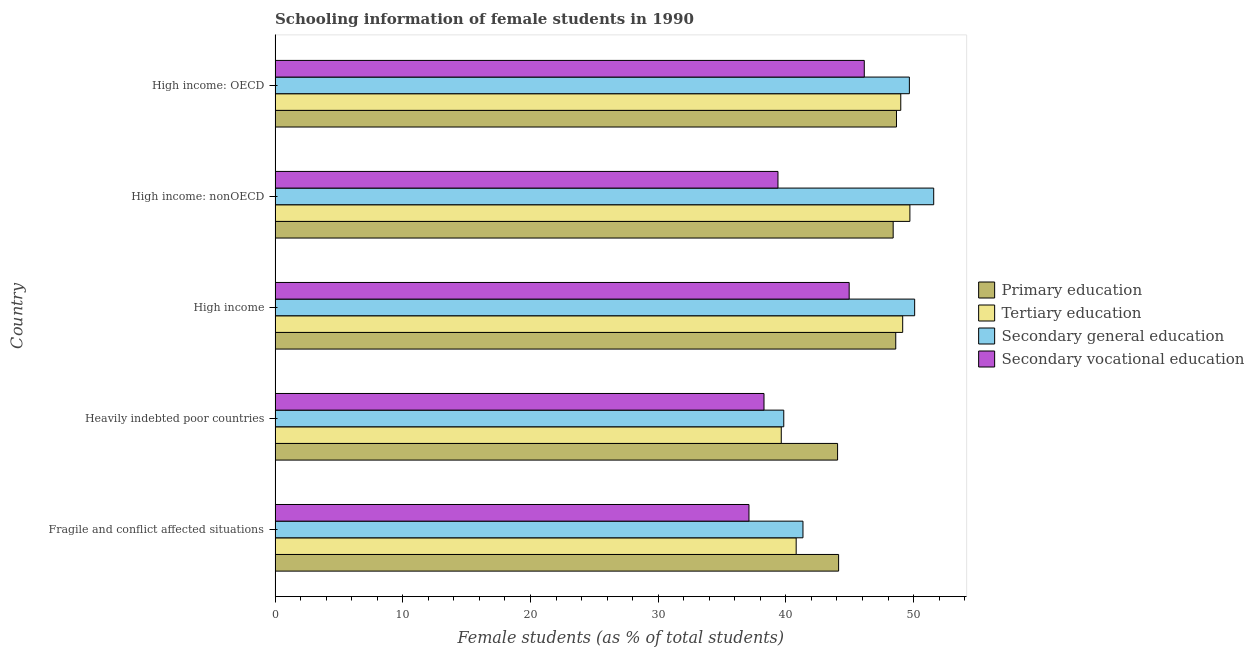How many different coloured bars are there?
Offer a very short reply. 4. How many bars are there on the 4th tick from the top?
Your response must be concise. 4. How many bars are there on the 5th tick from the bottom?
Ensure brevity in your answer.  4. What is the label of the 2nd group of bars from the top?
Your answer should be very brief. High income: nonOECD. In how many cases, is the number of bars for a given country not equal to the number of legend labels?
Provide a succinct answer. 0. What is the percentage of female students in secondary vocational education in High income: nonOECD?
Your answer should be compact. 39.38. Across all countries, what is the maximum percentage of female students in secondary vocational education?
Your answer should be compact. 46.14. Across all countries, what is the minimum percentage of female students in secondary vocational education?
Your response must be concise. 37.11. In which country was the percentage of female students in secondary education maximum?
Keep it short and to the point. High income: nonOECD. In which country was the percentage of female students in secondary education minimum?
Give a very brief answer. Heavily indebted poor countries. What is the total percentage of female students in primary education in the graph?
Ensure brevity in your answer.  233.85. What is the difference between the percentage of female students in primary education in High income and that in High income: nonOECD?
Keep it short and to the point. 0.2. What is the difference between the percentage of female students in tertiary education in High income and the percentage of female students in primary education in Heavily indebted poor countries?
Ensure brevity in your answer.  5.1. What is the average percentage of female students in tertiary education per country?
Keep it short and to the point. 45.66. What is the difference between the percentage of female students in primary education and percentage of female students in tertiary education in Heavily indebted poor countries?
Your answer should be very brief. 4.41. Is the difference between the percentage of female students in secondary vocational education in Fragile and conflict affected situations and High income: OECD greater than the difference between the percentage of female students in primary education in Fragile and conflict affected situations and High income: OECD?
Make the answer very short. No. What is the difference between the highest and the second highest percentage of female students in secondary vocational education?
Your response must be concise. 1.18. What is the difference between the highest and the lowest percentage of female students in secondary education?
Keep it short and to the point. 11.74. In how many countries, is the percentage of female students in tertiary education greater than the average percentage of female students in tertiary education taken over all countries?
Your response must be concise. 3. Is the sum of the percentage of female students in secondary education in Heavily indebted poor countries and High income: nonOECD greater than the maximum percentage of female students in primary education across all countries?
Provide a succinct answer. Yes. What does the 2nd bar from the top in High income represents?
Give a very brief answer. Secondary general education. What does the 4th bar from the bottom in High income: nonOECD represents?
Make the answer very short. Secondary vocational education. Are all the bars in the graph horizontal?
Make the answer very short. Yes. How many countries are there in the graph?
Provide a succinct answer. 5. What is the difference between two consecutive major ticks on the X-axis?
Provide a short and direct response. 10. Does the graph contain grids?
Make the answer very short. No. What is the title of the graph?
Your response must be concise. Schooling information of female students in 1990. What is the label or title of the X-axis?
Your answer should be very brief. Female students (as % of total students). What is the Female students (as % of total students) in Primary education in Fragile and conflict affected situations?
Provide a short and direct response. 44.13. What is the Female students (as % of total students) in Tertiary education in Fragile and conflict affected situations?
Keep it short and to the point. 40.81. What is the Female students (as % of total students) in Secondary general education in Fragile and conflict affected situations?
Your answer should be very brief. 41.34. What is the Female students (as % of total students) of Secondary vocational education in Fragile and conflict affected situations?
Keep it short and to the point. 37.11. What is the Female students (as % of total students) of Primary education in Heavily indebted poor countries?
Ensure brevity in your answer.  44.05. What is the Female students (as % of total students) in Tertiary education in Heavily indebted poor countries?
Your response must be concise. 39.64. What is the Female students (as % of total students) in Secondary general education in Heavily indebted poor countries?
Offer a very short reply. 39.84. What is the Female students (as % of total students) of Secondary vocational education in Heavily indebted poor countries?
Offer a terse response. 38.29. What is the Female students (as % of total students) of Primary education in High income?
Provide a succinct answer. 48.61. What is the Female students (as % of total students) of Tertiary education in High income?
Provide a succinct answer. 49.15. What is the Female students (as % of total students) of Secondary general education in High income?
Ensure brevity in your answer.  50.08. What is the Female students (as % of total students) in Secondary vocational education in High income?
Ensure brevity in your answer.  44.96. What is the Female students (as % of total students) of Primary education in High income: nonOECD?
Give a very brief answer. 48.4. What is the Female students (as % of total students) of Tertiary education in High income: nonOECD?
Keep it short and to the point. 49.71. What is the Female students (as % of total students) of Secondary general education in High income: nonOECD?
Keep it short and to the point. 51.58. What is the Female students (as % of total students) in Secondary vocational education in High income: nonOECD?
Your response must be concise. 39.38. What is the Female students (as % of total students) of Primary education in High income: OECD?
Ensure brevity in your answer.  48.66. What is the Female students (as % of total students) in Tertiary education in High income: OECD?
Your answer should be compact. 49. What is the Female students (as % of total students) in Secondary general education in High income: OECD?
Provide a short and direct response. 49.67. What is the Female students (as % of total students) in Secondary vocational education in High income: OECD?
Make the answer very short. 46.14. Across all countries, what is the maximum Female students (as % of total students) of Primary education?
Make the answer very short. 48.66. Across all countries, what is the maximum Female students (as % of total students) of Tertiary education?
Ensure brevity in your answer.  49.71. Across all countries, what is the maximum Female students (as % of total students) in Secondary general education?
Offer a terse response. 51.58. Across all countries, what is the maximum Female students (as % of total students) in Secondary vocational education?
Your answer should be very brief. 46.14. Across all countries, what is the minimum Female students (as % of total students) of Primary education?
Offer a very short reply. 44.05. Across all countries, what is the minimum Female students (as % of total students) in Tertiary education?
Offer a very short reply. 39.64. Across all countries, what is the minimum Female students (as % of total students) of Secondary general education?
Make the answer very short. 39.84. Across all countries, what is the minimum Female students (as % of total students) of Secondary vocational education?
Ensure brevity in your answer.  37.11. What is the total Female students (as % of total students) in Primary education in the graph?
Give a very brief answer. 233.85. What is the total Female students (as % of total students) of Tertiary education in the graph?
Keep it short and to the point. 228.3. What is the total Female students (as % of total students) in Secondary general education in the graph?
Your response must be concise. 232.51. What is the total Female students (as % of total students) in Secondary vocational education in the graph?
Your answer should be compact. 205.88. What is the difference between the Female students (as % of total students) in Primary education in Fragile and conflict affected situations and that in Heavily indebted poor countries?
Offer a very short reply. 0.08. What is the difference between the Female students (as % of total students) in Tertiary education in Fragile and conflict affected situations and that in Heavily indebted poor countries?
Provide a succinct answer. 1.17. What is the difference between the Female students (as % of total students) of Secondary general education in Fragile and conflict affected situations and that in Heavily indebted poor countries?
Offer a terse response. 1.5. What is the difference between the Female students (as % of total students) in Secondary vocational education in Fragile and conflict affected situations and that in Heavily indebted poor countries?
Your response must be concise. -1.18. What is the difference between the Female students (as % of total students) in Primary education in Fragile and conflict affected situations and that in High income?
Your answer should be compact. -4.47. What is the difference between the Female students (as % of total students) of Tertiary education in Fragile and conflict affected situations and that in High income?
Provide a succinct answer. -8.34. What is the difference between the Female students (as % of total students) in Secondary general education in Fragile and conflict affected situations and that in High income?
Your answer should be very brief. -8.75. What is the difference between the Female students (as % of total students) in Secondary vocational education in Fragile and conflict affected situations and that in High income?
Provide a short and direct response. -7.85. What is the difference between the Female students (as % of total students) of Primary education in Fragile and conflict affected situations and that in High income: nonOECD?
Your response must be concise. -4.27. What is the difference between the Female students (as % of total students) in Tertiary education in Fragile and conflict affected situations and that in High income: nonOECD?
Offer a very short reply. -8.9. What is the difference between the Female students (as % of total students) of Secondary general education in Fragile and conflict affected situations and that in High income: nonOECD?
Give a very brief answer. -10.24. What is the difference between the Female students (as % of total students) of Secondary vocational education in Fragile and conflict affected situations and that in High income: nonOECD?
Offer a terse response. -2.27. What is the difference between the Female students (as % of total students) of Primary education in Fragile and conflict affected situations and that in High income: OECD?
Provide a succinct answer. -4.53. What is the difference between the Female students (as % of total students) of Tertiary education in Fragile and conflict affected situations and that in High income: OECD?
Your response must be concise. -8.19. What is the difference between the Female students (as % of total students) of Secondary general education in Fragile and conflict affected situations and that in High income: OECD?
Ensure brevity in your answer.  -8.33. What is the difference between the Female students (as % of total students) in Secondary vocational education in Fragile and conflict affected situations and that in High income: OECD?
Provide a short and direct response. -9.03. What is the difference between the Female students (as % of total students) of Primary education in Heavily indebted poor countries and that in High income?
Ensure brevity in your answer.  -4.56. What is the difference between the Female students (as % of total students) in Tertiary education in Heavily indebted poor countries and that in High income?
Your answer should be very brief. -9.51. What is the difference between the Female students (as % of total students) of Secondary general education in Heavily indebted poor countries and that in High income?
Provide a succinct answer. -10.25. What is the difference between the Female students (as % of total students) of Secondary vocational education in Heavily indebted poor countries and that in High income?
Keep it short and to the point. -6.67. What is the difference between the Female students (as % of total students) in Primary education in Heavily indebted poor countries and that in High income: nonOECD?
Your response must be concise. -4.35. What is the difference between the Female students (as % of total students) of Tertiary education in Heavily indebted poor countries and that in High income: nonOECD?
Make the answer very short. -10.07. What is the difference between the Female students (as % of total students) of Secondary general education in Heavily indebted poor countries and that in High income: nonOECD?
Offer a very short reply. -11.74. What is the difference between the Female students (as % of total students) of Secondary vocational education in Heavily indebted poor countries and that in High income: nonOECD?
Your response must be concise. -1.09. What is the difference between the Female students (as % of total students) of Primary education in Heavily indebted poor countries and that in High income: OECD?
Provide a short and direct response. -4.61. What is the difference between the Female students (as % of total students) of Tertiary education in Heavily indebted poor countries and that in High income: OECD?
Keep it short and to the point. -9.36. What is the difference between the Female students (as % of total students) in Secondary general education in Heavily indebted poor countries and that in High income: OECD?
Provide a succinct answer. -9.84. What is the difference between the Female students (as % of total students) of Secondary vocational education in Heavily indebted poor countries and that in High income: OECD?
Keep it short and to the point. -7.85. What is the difference between the Female students (as % of total students) in Primary education in High income and that in High income: nonOECD?
Give a very brief answer. 0.2. What is the difference between the Female students (as % of total students) of Tertiary education in High income and that in High income: nonOECD?
Give a very brief answer. -0.56. What is the difference between the Female students (as % of total students) in Secondary general education in High income and that in High income: nonOECD?
Your response must be concise. -1.49. What is the difference between the Female students (as % of total students) in Secondary vocational education in High income and that in High income: nonOECD?
Your answer should be very brief. 5.58. What is the difference between the Female students (as % of total students) of Primary education in High income and that in High income: OECD?
Your answer should be very brief. -0.06. What is the difference between the Female students (as % of total students) of Tertiary education in High income and that in High income: OECD?
Your answer should be very brief. 0.15. What is the difference between the Female students (as % of total students) in Secondary general education in High income and that in High income: OECD?
Keep it short and to the point. 0.41. What is the difference between the Female students (as % of total students) of Secondary vocational education in High income and that in High income: OECD?
Your response must be concise. -1.18. What is the difference between the Female students (as % of total students) in Primary education in High income: nonOECD and that in High income: OECD?
Offer a terse response. -0.26. What is the difference between the Female students (as % of total students) in Tertiary education in High income: nonOECD and that in High income: OECD?
Keep it short and to the point. 0.71. What is the difference between the Female students (as % of total students) in Secondary general education in High income: nonOECD and that in High income: OECD?
Your answer should be very brief. 1.91. What is the difference between the Female students (as % of total students) of Secondary vocational education in High income: nonOECD and that in High income: OECD?
Give a very brief answer. -6.76. What is the difference between the Female students (as % of total students) in Primary education in Fragile and conflict affected situations and the Female students (as % of total students) in Tertiary education in Heavily indebted poor countries?
Offer a terse response. 4.49. What is the difference between the Female students (as % of total students) in Primary education in Fragile and conflict affected situations and the Female students (as % of total students) in Secondary general education in Heavily indebted poor countries?
Your response must be concise. 4.3. What is the difference between the Female students (as % of total students) of Primary education in Fragile and conflict affected situations and the Female students (as % of total students) of Secondary vocational education in Heavily indebted poor countries?
Keep it short and to the point. 5.84. What is the difference between the Female students (as % of total students) of Tertiary education in Fragile and conflict affected situations and the Female students (as % of total students) of Secondary general education in Heavily indebted poor countries?
Your answer should be compact. 0.97. What is the difference between the Female students (as % of total students) in Tertiary education in Fragile and conflict affected situations and the Female students (as % of total students) in Secondary vocational education in Heavily indebted poor countries?
Give a very brief answer. 2.52. What is the difference between the Female students (as % of total students) of Secondary general education in Fragile and conflict affected situations and the Female students (as % of total students) of Secondary vocational education in Heavily indebted poor countries?
Offer a terse response. 3.05. What is the difference between the Female students (as % of total students) in Primary education in Fragile and conflict affected situations and the Female students (as % of total students) in Tertiary education in High income?
Make the answer very short. -5.02. What is the difference between the Female students (as % of total students) of Primary education in Fragile and conflict affected situations and the Female students (as % of total students) of Secondary general education in High income?
Keep it short and to the point. -5.95. What is the difference between the Female students (as % of total students) in Primary education in Fragile and conflict affected situations and the Female students (as % of total students) in Secondary vocational education in High income?
Make the answer very short. -0.83. What is the difference between the Female students (as % of total students) in Tertiary education in Fragile and conflict affected situations and the Female students (as % of total students) in Secondary general education in High income?
Ensure brevity in your answer.  -9.28. What is the difference between the Female students (as % of total students) of Tertiary education in Fragile and conflict affected situations and the Female students (as % of total students) of Secondary vocational education in High income?
Your answer should be compact. -4.15. What is the difference between the Female students (as % of total students) in Secondary general education in Fragile and conflict affected situations and the Female students (as % of total students) in Secondary vocational education in High income?
Your answer should be compact. -3.62. What is the difference between the Female students (as % of total students) of Primary education in Fragile and conflict affected situations and the Female students (as % of total students) of Tertiary education in High income: nonOECD?
Make the answer very short. -5.58. What is the difference between the Female students (as % of total students) of Primary education in Fragile and conflict affected situations and the Female students (as % of total students) of Secondary general education in High income: nonOECD?
Offer a very short reply. -7.45. What is the difference between the Female students (as % of total students) in Primary education in Fragile and conflict affected situations and the Female students (as % of total students) in Secondary vocational education in High income: nonOECD?
Offer a very short reply. 4.75. What is the difference between the Female students (as % of total students) of Tertiary education in Fragile and conflict affected situations and the Female students (as % of total students) of Secondary general education in High income: nonOECD?
Give a very brief answer. -10.77. What is the difference between the Female students (as % of total students) in Tertiary education in Fragile and conflict affected situations and the Female students (as % of total students) in Secondary vocational education in High income: nonOECD?
Offer a terse response. 1.43. What is the difference between the Female students (as % of total students) of Secondary general education in Fragile and conflict affected situations and the Female students (as % of total students) of Secondary vocational education in High income: nonOECD?
Offer a terse response. 1.96. What is the difference between the Female students (as % of total students) in Primary education in Fragile and conflict affected situations and the Female students (as % of total students) in Tertiary education in High income: OECD?
Your answer should be very brief. -4.87. What is the difference between the Female students (as % of total students) in Primary education in Fragile and conflict affected situations and the Female students (as % of total students) in Secondary general education in High income: OECD?
Ensure brevity in your answer.  -5.54. What is the difference between the Female students (as % of total students) of Primary education in Fragile and conflict affected situations and the Female students (as % of total students) of Secondary vocational education in High income: OECD?
Make the answer very short. -2.01. What is the difference between the Female students (as % of total students) in Tertiary education in Fragile and conflict affected situations and the Female students (as % of total students) in Secondary general education in High income: OECD?
Provide a succinct answer. -8.86. What is the difference between the Female students (as % of total students) of Tertiary education in Fragile and conflict affected situations and the Female students (as % of total students) of Secondary vocational education in High income: OECD?
Offer a terse response. -5.33. What is the difference between the Female students (as % of total students) of Secondary general education in Fragile and conflict affected situations and the Female students (as % of total students) of Secondary vocational education in High income: OECD?
Your response must be concise. -4.8. What is the difference between the Female students (as % of total students) in Primary education in Heavily indebted poor countries and the Female students (as % of total students) in Tertiary education in High income?
Ensure brevity in your answer.  -5.1. What is the difference between the Female students (as % of total students) of Primary education in Heavily indebted poor countries and the Female students (as % of total students) of Secondary general education in High income?
Provide a short and direct response. -6.04. What is the difference between the Female students (as % of total students) in Primary education in Heavily indebted poor countries and the Female students (as % of total students) in Secondary vocational education in High income?
Your answer should be compact. -0.91. What is the difference between the Female students (as % of total students) of Tertiary education in Heavily indebted poor countries and the Female students (as % of total students) of Secondary general education in High income?
Offer a very short reply. -10.45. What is the difference between the Female students (as % of total students) in Tertiary education in Heavily indebted poor countries and the Female students (as % of total students) in Secondary vocational education in High income?
Offer a very short reply. -5.32. What is the difference between the Female students (as % of total students) in Secondary general education in Heavily indebted poor countries and the Female students (as % of total students) in Secondary vocational education in High income?
Give a very brief answer. -5.12. What is the difference between the Female students (as % of total students) of Primary education in Heavily indebted poor countries and the Female students (as % of total students) of Tertiary education in High income: nonOECD?
Make the answer very short. -5.66. What is the difference between the Female students (as % of total students) of Primary education in Heavily indebted poor countries and the Female students (as % of total students) of Secondary general education in High income: nonOECD?
Your answer should be very brief. -7.53. What is the difference between the Female students (as % of total students) of Primary education in Heavily indebted poor countries and the Female students (as % of total students) of Secondary vocational education in High income: nonOECD?
Give a very brief answer. 4.67. What is the difference between the Female students (as % of total students) of Tertiary education in Heavily indebted poor countries and the Female students (as % of total students) of Secondary general education in High income: nonOECD?
Offer a very short reply. -11.94. What is the difference between the Female students (as % of total students) of Tertiary education in Heavily indebted poor countries and the Female students (as % of total students) of Secondary vocational education in High income: nonOECD?
Provide a short and direct response. 0.26. What is the difference between the Female students (as % of total students) of Secondary general education in Heavily indebted poor countries and the Female students (as % of total students) of Secondary vocational education in High income: nonOECD?
Ensure brevity in your answer.  0.45. What is the difference between the Female students (as % of total students) of Primary education in Heavily indebted poor countries and the Female students (as % of total students) of Tertiary education in High income: OECD?
Offer a very short reply. -4.95. What is the difference between the Female students (as % of total students) of Primary education in Heavily indebted poor countries and the Female students (as % of total students) of Secondary general education in High income: OECD?
Offer a terse response. -5.62. What is the difference between the Female students (as % of total students) of Primary education in Heavily indebted poor countries and the Female students (as % of total students) of Secondary vocational education in High income: OECD?
Keep it short and to the point. -2.09. What is the difference between the Female students (as % of total students) in Tertiary education in Heavily indebted poor countries and the Female students (as % of total students) in Secondary general education in High income: OECD?
Make the answer very short. -10.03. What is the difference between the Female students (as % of total students) of Tertiary education in Heavily indebted poor countries and the Female students (as % of total students) of Secondary vocational education in High income: OECD?
Provide a succinct answer. -6.5. What is the difference between the Female students (as % of total students) in Secondary general education in Heavily indebted poor countries and the Female students (as % of total students) in Secondary vocational education in High income: OECD?
Your answer should be very brief. -6.3. What is the difference between the Female students (as % of total students) of Primary education in High income and the Female students (as % of total students) of Tertiary education in High income: nonOECD?
Your response must be concise. -1.11. What is the difference between the Female students (as % of total students) in Primary education in High income and the Female students (as % of total students) in Secondary general education in High income: nonOECD?
Provide a succinct answer. -2.97. What is the difference between the Female students (as % of total students) in Primary education in High income and the Female students (as % of total students) in Secondary vocational education in High income: nonOECD?
Provide a succinct answer. 9.22. What is the difference between the Female students (as % of total students) of Tertiary education in High income and the Female students (as % of total students) of Secondary general education in High income: nonOECD?
Offer a terse response. -2.43. What is the difference between the Female students (as % of total students) of Tertiary education in High income and the Female students (as % of total students) of Secondary vocational education in High income: nonOECD?
Ensure brevity in your answer.  9.77. What is the difference between the Female students (as % of total students) in Secondary general education in High income and the Female students (as % of total students) in Secondary vocational education in High income: nonOECD?
Offer a terse response. 10.7. What is the difference between the Female students (as % of total students) in Primary education in High income and the Female students (as % of total students) in Tertiary education in High income: OECD?
Provide a short and direct response. -0.39. What is the difference between the Female students (as % of total students) in Primary education in High income and the Female students (as % of total students) in Secondary general education in High income: OECD?
Your answer should be compact. -1.07. What is the difference between the Female students (as % of total students) of Primary education in High income and the Female students (as % of total students) of Secondary vocational education in High income: OECD?
Provide a short and direct response. 2.47. What is the difference between the Female students (as % of total students) in Tertiary education in High income and the Female students (as % of total students) in Secondary general education in High income: OECD?
Keep it short and to the point. -0.52. What is the difference between the Female students (as % of total students) of Tertiary education in High income and the Female students (as % of total students) of Secondary vocational education in High income: OECD?
Your answer should be very brief. 3.01. What is the difference between the Female students (as % of total students) of Secondary general education in High income and the Female students (as % of total students) of Secondary vocational education in High income: OECD?
Keep it short and to the point. 3.94. What is the difference between the Female students (as % of total students) in Primary education in High income: nonOECD and the Female students (as % of total students) in Tertiary education in High income: OECD?
Offer a terse response. -0.6. What is the difference between the Female students (as % of total students) in Primary education in High income: nonOECD and the Female students (as % of total students) in Secondary general education in High income: OECD?
Your answer should be very brief. -1.27. What is the difference between the Female students (as % of total students) in Primary education in High income: nonOECD and the Female students (as % of total students) in Secondary vocational education in High income: OECD?
Your answer should be compact. 2.26. What is the difference between the Female students (as % of total students) of Tertiary education in High income: nonOECD and the Female students (as % of total students) of Secondary general education in High income: OECD?
Make the answer very short. 0.04. What is the difference between the Female students (as % of total students) of Tertiary education in High income: nonOECD and the Female students (as % of total students) of Secondary vocational education in High income: OECD?
Your answer should be very brief. 3.57. What is the difference between the Female students (as % of total students) of Secondary general education in High income: nonOECD and the Female students (as % of total students) of Secondary vocational education in High income: OECD?
Provide a short and direct response. 5.44. What is the average Female students (as % of total students) in Primary education per country?
Offer a terse response. 46.77. What is the average Female students (as % of total students) of Tertiary education per country?
Ensure brevity in your answer.  45.66. What is the average Female students (as % of total students) in Secondary general education per country?
Your answer should be compact. 46.5. What is the average Female students (as % of total students) of Secondary vocational education per country?
Keep it short and to the point. 41.18. What is the difference between the Female students (as % of total students) of Primary education and Female students (as % of total students) of Tertiary education in Fragile and conflict affected situations?
Make the answer very short. 3.32. What is the difference between the Female students (as % of total students) of Primary education and Female students (as % of total students) of Secondary general education in Fragile and conflict affected situations?
Give a very brief answer. 2.79. What is the difference between the Female students (as % of total students) in Primary education and Female students (as % of total students) in Secondary vocational education in Fragile and conflict affected situations?
Offer a terse response. 7.02. What is the difference between the Female students (as % of total students) in Tertiary education and Female students (as % of total students) in Secondary general education in Fragile and conflict affected situations?
Offer a very short reply. -0.53. What is the difference between the Female students (as % of total students) of Tertiary education and Female students (as % of total students) of Secondary vocational education in Fragile and conflict affected situations?
Ensure brevity in your answer.  3.7. What is the difference between the Female students (as % of total students) of Secondary general education and Female students (as % of total students) of Secondary vocational education in Fragile and conflict affected situations?
Your answer should be compact. 4.23. What is the difference between the Female students (as % of total students) of Primary education and Female students (as % of total students) of Tertiary education in Heavily indebted poor countries?
Make the answer very short. 4.41. What is the difference between the Female students (as % of total students) of Primary education and Female students (as % of total students) of Secondary general education in Heavily indebted poor countries?
Keep it short and to the point. 4.21. What is the difference between the Female students (as % of total students) of Primary education and Female students (as % of total students) of Secondary vocational education in Heavily indebted poor countries?
Your response must be concise. 5.76. What is the difference between the Female students (as % of total students) in Tertiary education and Female students (as % of total students) in Secondary general education in Heavily indebted poor countries?
Your answer should be compact. -0.2. What is the difference between the Female students (as % of total students) in Tertiary education and Female students (as % of total students) in Secondary vocational education in Heavily indebted poor countries?
Make the answer very short. 1.35. What is the difference between the Female students (as % of total students) in Secondary general education and Female students (as % of total students) in Secondary vocational education in Heavily indebted poor countries?
Your response must be concise. 1.55. What is the difference between the Female students (as % of total students) in Primary education and Female students (as % of total students) in Tertiary education in High income?
Offer a very short reply. -0.54. What is the difference between the Female students (as % of total students) of Primary education and Female students (as % of total students) of Secondary general education in High income?
Your answer should be compact. -1.48. What is the difference between the Female students (as % of total students) of Primary education and Female students (as % of total students) of Secondary vocational education in High income?
Keep it short and to the point. 3.65. What is the difference between the Female students (as % of total students) of Tertiary education and Female students (as % of total students) of Secondary general education in High income?
Keep it short and to the point. -0.94. What is the difference between the Female students (as % of total students) of Tertiary education and Female students (as % of total students) of Secondary vocational education in High income?
Provide a short and direct response. 4.19. What is the difference between the Female students (as % of total students) in Secondary general education and Female students (as % of total students) in Secondary vocational education in High income?
Your answer should be very brief. 5.13. What is the difference between the Female students (as % of total students) in Primary education and Female students (as % of total students) in Tertiary education in High income: nonOECD?
Offer a very short reply. -1.31. What is the difference between the Female students (as % of total students) of Primary education and Female students (as % of total students) of Secondary general education in High income: nonOECD?
Ensure brevity in your answer.  -3.17. What is the difference between the Female students (as % of total students) in Primary education and Female students (as % of total students) in Secondary vocational education in High income: nonOECD?
Make the answer very short. 9.02. What is the difference between the Female students (as % of total students) in Tertiary education and Female students (as % of total students) in Secondary general education in High income: nonOECD?
Provide a succinct answer. -1.86. What is the difference between the Female students (as % of total students) in Tertiary education and Female students (as % of total students) in Secondary vocational education in High income: nonOECD?
Your answer should be compact. 10.33. What is the difference between the Female students (as % of total students) of Secondary general education and Female students (as % of total students) of Secondary vocational education in High income: nonOECD?
Give a very brief answer. 12.2. What is the difference between the Female students (as % of total students) in Primary education and Female students (as % of total students) in Tertiary education in High income: OECD?
Your answer should be compact. -0.34. What is the difference between the Female students (as % of total students) of Primary education and Female students (as % of total students) of Secondary general education in High income: OECD?
Provide a succinct answer. -1.01. What is the difference between the Female students (as % of total students) in Primary education and Female students (as % of total students) in Secondary vocational education in High income: OECD?
Make the answer very short. 2.52. What is the difference between the Female students (as % of total students) of Tertiary education and Female students (as % of total students) of Secondary general education in High income: OECD?
Keep it short and to the point. -0.67. What is the difference between the Female students (as % of total students) in Tertiary education and Female students (as % of total students) in Secondary vocational education in High income: OECD?
Provide a succinct answer. 2.86. What is the difference between the Female students (as % of total students) in Secondary general education and Female students (as % of total students) in Secondary vocational education in High income: OECD?
Keep it short and to the point. 3.53. What is the ratio of the Female students (as % of total students) of Primary education in Fragile and conflict affected situations to that in Heavily indebted poor countries?
Make the answer very short. 1. What is the ratio of the Female students (as % of total students) of Tertiary education in Fragile and conflict affected situations to that in Heavily indebted poor countries?
Your answer should be compact. 1.03. What is the ratio of the Female students (as % of total students) of Secondary general education in Fragile and conflict affected situations to that in Heavily indebted poor countries?
Keep it short and to the point. 1.04. What is the ratio of the Female students (as % of total students) of Secondary vocational education in Fragile and conflict affected situations to that in Heavily indebted poor countries?
Offer a very short reply. 0.97. What is the ratio of the Female students (as % of total students) in Primary education in Fragile and conflict affected situations to that in High income?
Offer a terse response. 0.91. What is the ratio of the Female students (as % of total students) of Tertiary education in Fragile and conflict affected situations to that in High income?
Your answer should be compact. 0.83. What is the ratio of the Female students (as % of total students) of Secondary general education in Fragile and conflict affected situations to that in High income?
Keep it short and to the point. 0.83. What is the ratio of the Female students (as % of total students) in Secondary vocational education in Fragile and conflict affected situations to that in High income?
Your response must be concise. 0.83. What is the ratio of the Female students (as % of total students) of Primary education in Fragile and conflict affected situations to that in High income: nonOECD?
Your answer should be very brief. 0.91. What is the ratio of the Female students (as % of total students) of Tertiary education in Fragile and conflict affected situations to that in High income: nonOECD?
Make the answer very short. 0.82. What is the ratio of the Female students (as % of total students) in Secondary general education in Fragile and conflict affected situations to that in High income: nonOECD?
Offer a very short reply. 0.8. What is the ratio of the Female students (as % of total students) in Secondary vocational education in Fragile and conflict affected situations to that in High income: nonOECD?
Offer a very short reply. 0.94. What is the ratio of the Female students (as % of total students) in Primary education in Fragile and conflict affected situations to that in High income: OECD?
Your answer should be compact. 0.91. What is the ratio of the Female students (as % of total students) of Tertiary education in Fragile and conflict affected situations to that in High income: OECD?
Give a very brief answer. 0.83. What is the ratio of the Female students (as % of total students) of Secondary general education in Fragile and conflict affected situations to that in High income: OECD?
Offer a very short reply. 0.83. What is the ratio of the Female students (as % of total students) in Secondary vocational education in Fragile and conflict affected situations to that in High income: OECD?
Your response must be concise. 0.8. What is the ratio of the Female students (as % of total students) in Primary education in Heavily indebted poor countries to that in High income?
Keep it short and to the point. 0.91. What is the ratio of the Female students (as % of total students) in Tertiary education in Heavily indebted poor countries to that in High income?
Your answer should be very brief. 0.81. What is the ratio of the Female students (as % of total students) in Secondary general education in Heavily indebted poor countries to that in High income?
Keep it short and to the point. 0.8. What is the ratio of the Female students (as % of total students) of Secondary vocational education in Heavily indebted poor countries to that in High income?
Your answer should be compact. 0.85. What is the ratio of the Female students (as % of total students) of Primary education in Heavily indebted poor countries to that in High income: nonOECD?
Make the answer very short. 0.91. What is the ratio of the Female students (as % of total students) in Tertiary education in Heavily indebted poor countries to that in High income: nonOECD?
Your answer should be very brief. 0.8. What is the ratio of the Female students (as % of total students) of Secondary general education in Heavily indebted poor countries to that in High income: nonOECD?
Your answer should be compact. 0.77. What is the ratio of the Female students (as % of total students) in Secondary vocational education in Heavily indebted poor countries to that in High income: nonOECD?
Your answer should be very brief. 0.97. What is the ratio of the Female students (as % of total students) in Primary education in Heavily indebted poor countries to that in High income: OECD?
Offer a very short reply. 0.91. What is the ratio of the Female students (as % of total students) in Tertiary education in Heavily indebted poor countries to that in High income: OECD?
Ensure brevity in your answer.  0.81. What is the ratio of the Female students (as % of total students) of Secondary general education in Heavily indebted poor countries to that in High income: OECD?
Your response must be concise. 0.8. What is the ratio of the Female students (as % of total students) in Secondary vocational education in Heavily indebted poor countries to that in High income: OECD?
Ensure brevity in your answer.  0.83. What is the ratio of the Female students (as % of total students) in Tertiary education in High income to that in High income: nonOECD?
Your answer should be compact. 0.99. What is the ratio of the Female students (as % of total students) of Secondary general education in High income to that in High income: nonOECD?
Ensure brevity in your answer.  0.97. What is the ratio of the Female students (as % of total students) in Secondary vocational education in High income to that in High income: nonOECD?
Ensure brevity in your answer.  1.14. What is the ratio of the Female students (as % of total students) in Primary education in High income to that in High income: OECD?
Provide a succinct answer. 1. What is the ratio of the Female students (as % of total students) of Tertiary education in High income to that in High income: OECD?
Your response must be concise. 1. What is the ratio of the Female students (as % of total students) in Secondary general education in High income to that in High income: OECD?
Make the answer very short. 1.01. What is the ratio of the Female students (as % of total students) of Secondary vocational education in High income to that in High income: OECD?
Offer a terse response. 0.97. What is the ratio of the Female students (as % of total students) in Primary education in High income: nonOECD to that in High income: OECD?
Keep it short and to the point. 0.99. What is the ratio of the Female students (as % of total students) of Tertiary education in High income: nonOECD to that in High income: OECD?
Give a very brief answer. 1.01. What is the ratio of the Female students (as % of total students) of Secondary general education in High income: nonOECD to that in High income: OECD?
Make the answer very short. 1.04. What is the ratio of the Female students (as % of total students) of Secondary vocational education in High income: nonOECD to that in High income: OECD?
Your answer should be very brief. 0.85. What is the difference between the highest and the second highest Female students (as % of total students) of Primary education?
Your response must be concise. 0.06. What is the difference between the highest and the second highest Female students (as % of total students) in Tertiary education?
Your answer should be compact. 0.56. What is the difference between the highest and the second highest Female students (as % of total students) in Secondary general education?
Ensure brevity in your answer.  1.49. What is the difference between the highest and the second highest Female students (as % of total students) of Secondary vocational education?
Your answer should be compact. 1.18. What is the difference between the highest and the lowest Female students (as % of total students) of Primary education?
Make the answer very short. 4.61. What is the difference between the highest and the lowest Female students (as % of total students) of Tertiary education?
Provide a succinct answer. 10.07. What is the difference between the highest and the lowest Female students (as % of total students) in Secondary general education?
Your answer should be compact. 11.74. What is the difference between the highest and the lowest Female students (as % of total students) of Secondary vocational education?
Your answer should be very brief. 9.03. 